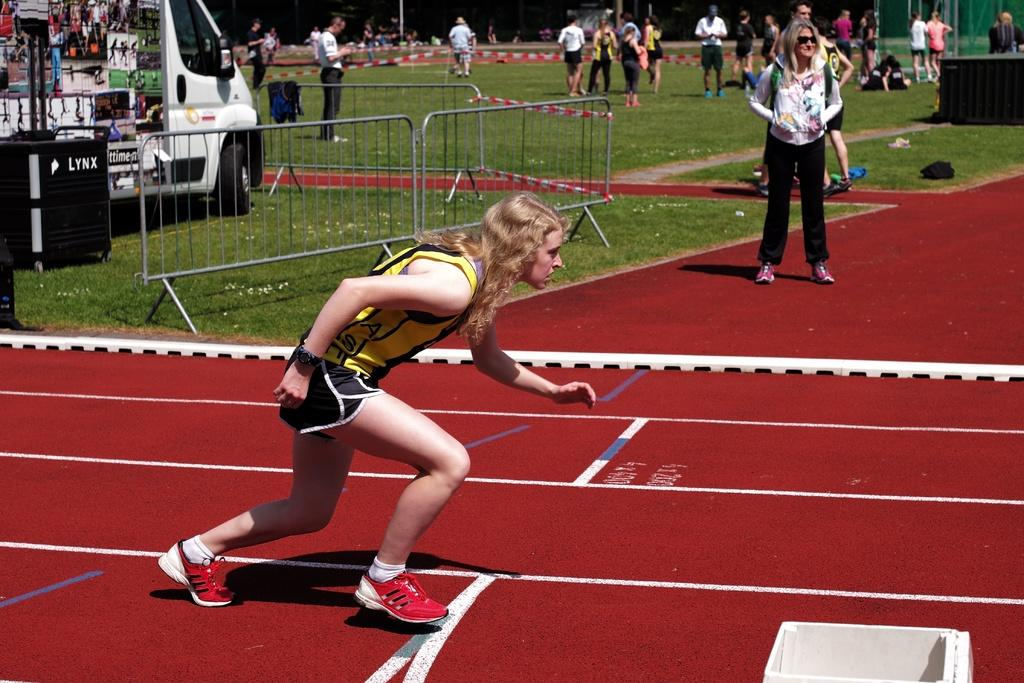Provide a one-sentence caption for the provided image. A woman prepares to run on a track in front of a LYNX container. 